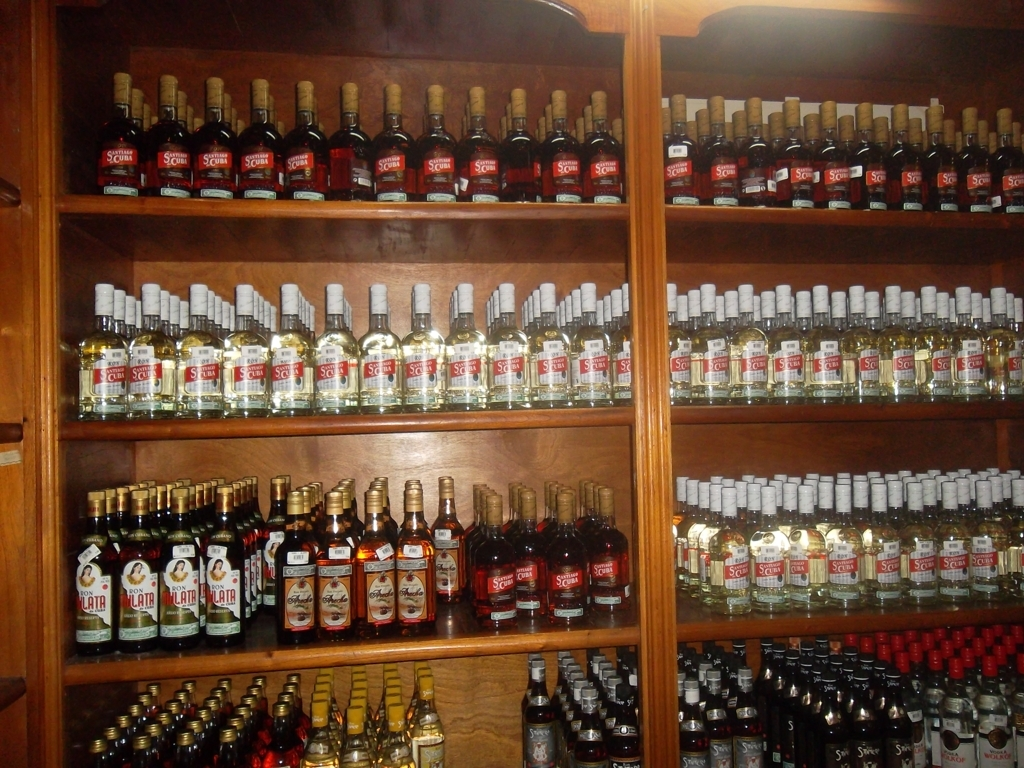What can this image tell us about the storage conditions necessary for these beverages? The image implies that these beverages are stored upright to maintain the integrity of the seal and prevent the cork or cap from deteriorating due to prolonged contact with the liquid. The wooden shelving and the lack of direct sunlight suggest an effort to keep them in a cool, stable environment that's optimal for preserving flavor and quality. 